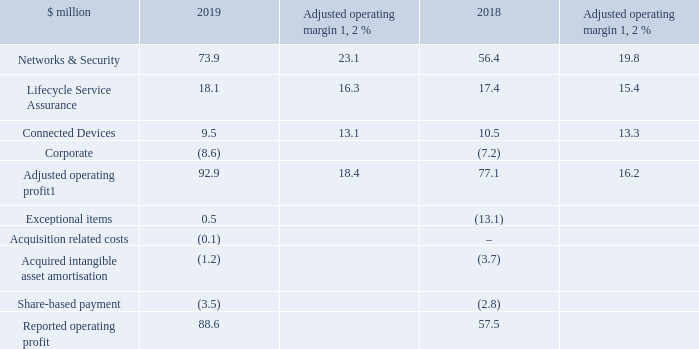Operating profit
Notes
1. Before exceptional items, acquisition related costs, acquired intangible asset amortisation and share-based payment amounting to $4.3 million in total (2018 $19.6 million).
2. Adjusted operating profit as a percentage of revenue in the period.
Adjusted operating profit increased by $15.8 million or 20.5 per cent to $92.9 million in 2019, compared with $77.1 million in 2018. Adjusted operating margin increased by 2.2 per cent to 18.4 per cent, from 16.2 per cent in 2018.
Reported operating profit was up by $31.1 million or 54.1 per cent to $88.6 million (2018 $57.5 million). Total adjusting items were lower in 2019 at $4.3 million, compared to $19.6 million in 2018, mainly due to exceptional items totalling $13.1 million charged last year (see below).
What was the adjusted operating margin in 2018? 16.2 per cent. What was the reported operating profit in 2019? $88.6 million. What were the items factored into the adjusted operating profit to derive the reported operating profit in 2019? Exceptional items, acquisition related costs, acquired intangible asset amortisation, share-based payment. In which year was the adjusted operating margin for Lifecycle Service Assurance larger? 16.3%>15.4%
Answer: 2019. What was the change in operating profit under Networks & Security?
Answer scale should be: million. 73.9-56.4
Answer: 17.5. What was the percentage change in operating profit under Networks & Security?
Answer scale should be: percent. (73.9-56.4)/56.4
Answer: 31.03. 